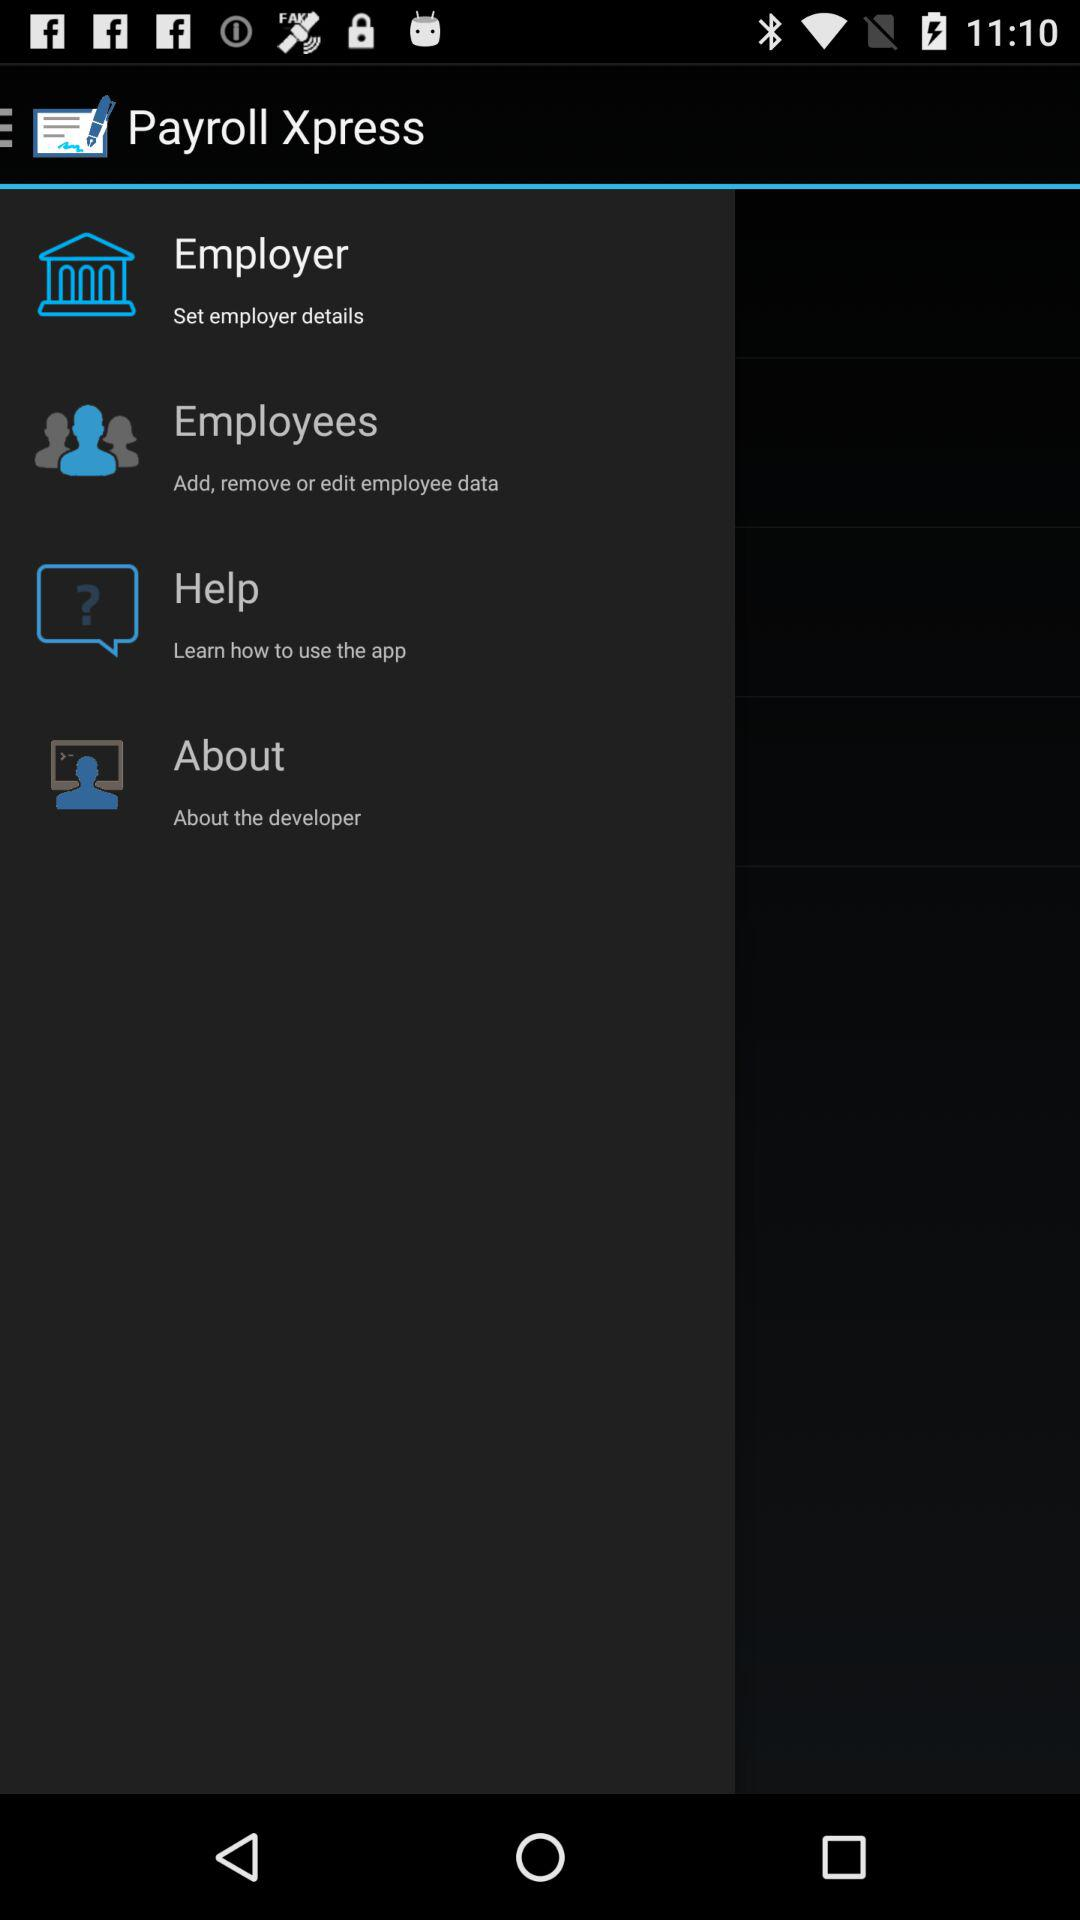Who is the employer?
When the provided information is insufficient, respond with <no answer>. <no answer> 